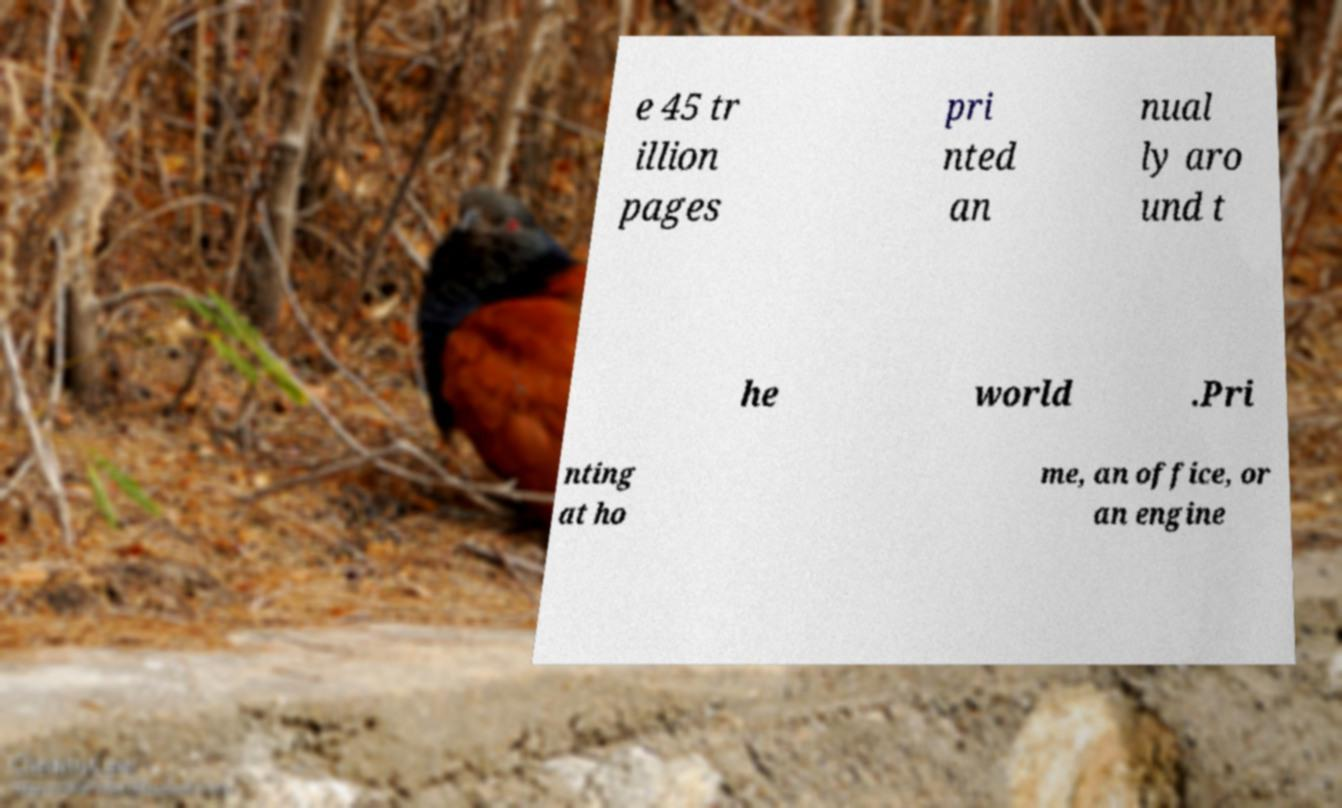For documentation purposes, I need the text within this image transcribed. Could you provide that? e 45 tr illion pages pri nted an nual ly aro und t he world .Pri nting at ho me, an office, or an engine 